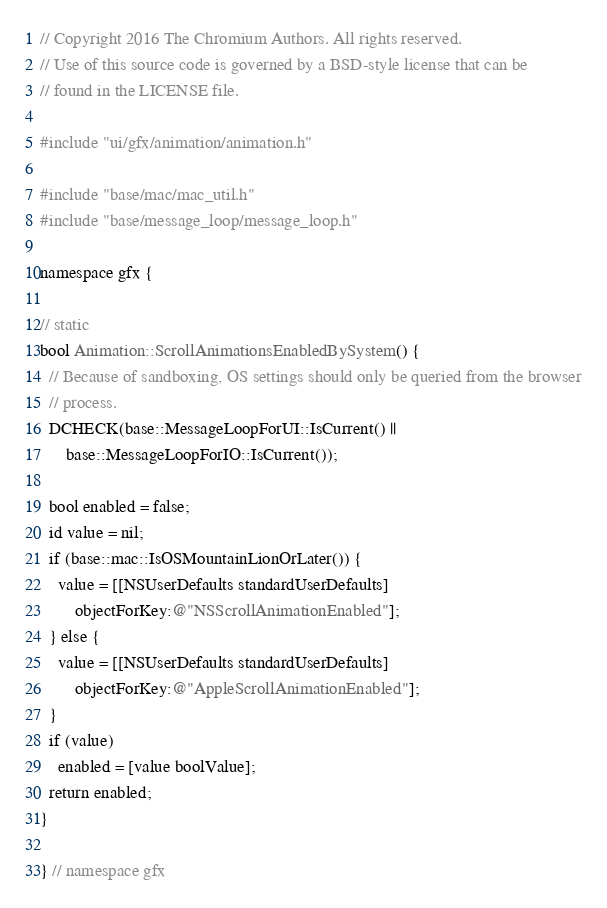<code> <loc_0><loc_0><loc_500><loc_500><_ObjectiveC_>// Copyright 2016 The Chromium Authors. All rights reserved.
// Use of this source code is governed by a BSD-style license that can be
// found in the LICENSE file.

#include "ui/gfx/animation/animation.h"

#include "base/mac/mac_util.h"
#include "base/message_loop/message_loop.h"

namespace gfx {

// static
bool Animation::ScrollAnimationsEnabledBySystem() {
  // Because of sandboxing, OS settings should only be queried from the browser
  // process.
  DCHECK(base::MessageLoopForUI::IsCurrent() ||
      base::MessageLoopForIO::IsCurrent());

  bool enabled = false;
  id value = nil;
  if (base::mac::IsOSMountainLionOrLater()) {
    value = [[NSUserDefaults standardUserDefaults]
        objectForKey:@"NSScrollAnimationEnabled"];
  } else {
    value = [[NSUserDefaults standardUserDefaults]
        objectForKey:@"AppleScrollAnimationEnabled"];
  }
  if (value)
    enabled = [value boolValue];
  return enabled;
}

} // namespace gfx
</code> 